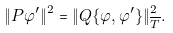Convert formula to latex. <formula><loc_0><loc_0><loc_500><loc_500>\| P \varphi ^ { \prime } \| ^ { 2 } = \| Q \{ \varphi , \varphi ^ { \prime } \} \| _ { \overline { T } } ^ { 2 } .</formula> 